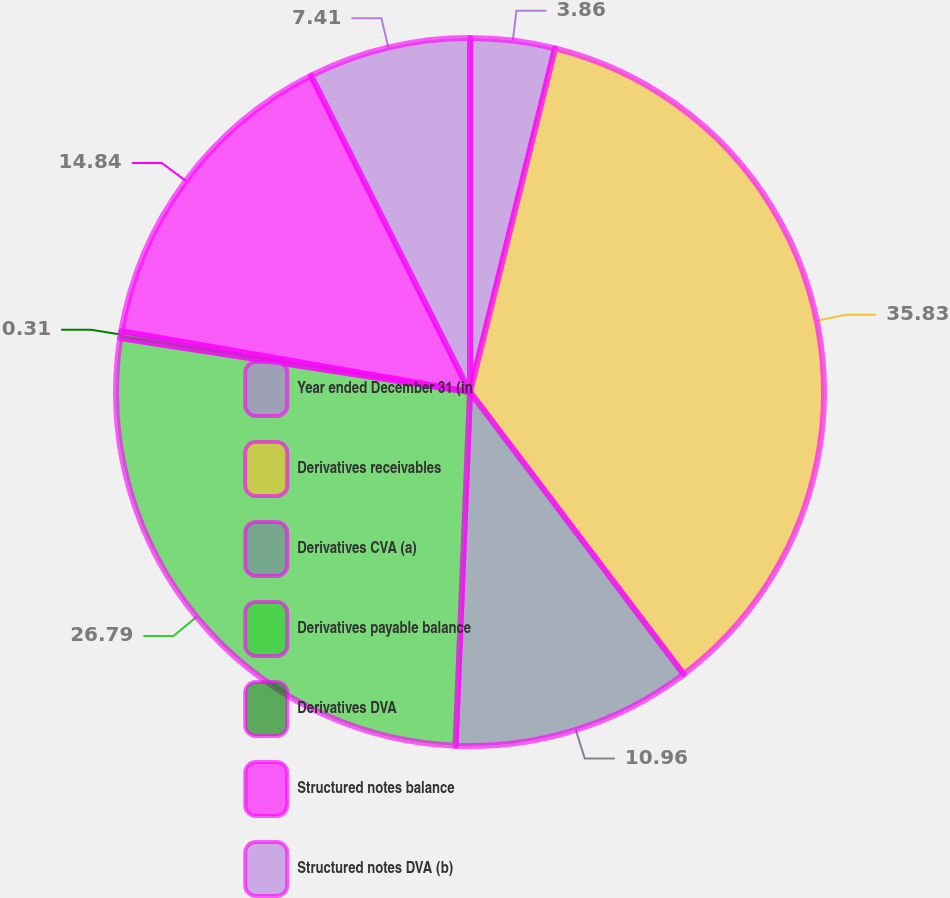Convert chart to OTSL. <chart><loc_0><loc_0><loc_500><loc_500><pie_chart><fcel>Year ended December 31 (in<fcel>Derivatives receivables<fcel>Derivatives CVA (a)<fcel>Derivatives payable balance<fcel>Derivatives DVA<fcel>Structured notes balance<fcel>Structured notes DVA (b)<nl><fcel>3.86%<fcel>35.83%<fcel>10.96%<fcel>26.79%<fcel>0.31%<fcel>14.84%<fcel>7.41%<nl></chart> 